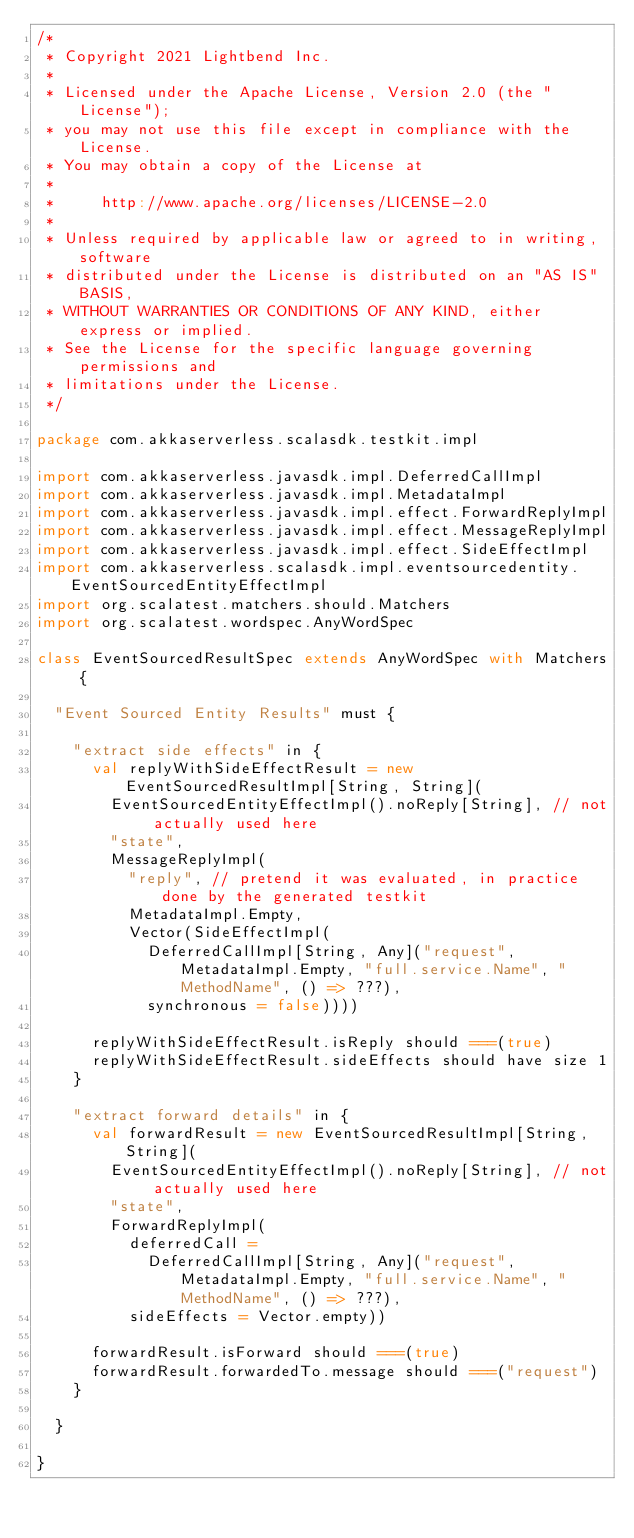Convert code to text. <code><loc_0><loc_0><loc_500><loc_500><_Scala_>/*
 * Copyright 2021 Lightbend Inc.
 *
 * Licensed under the Apache License, Version 2.0 (the "License");
 * you may not use this file except in compliance with the License.
 * You may obtain a copy of the License at
 *
 *     http://www.apache.org/licenses/LICENSE-2.0
 *
 * Unless required by applicable law or agreed to in writing, software
 * distributed under the License is distributed on an "AS IS" BASIS,
 * WITHOUT WARRANTIES OR CONDITIONS OF ANY KIND, either express or implied.
 * See the License for the specific language governing permissions and
 * limitations under the License.
 */

package com.akkaserverless.scalasdk.testkit.impl

import com.akkaserverless.javasdk.impl.DeferredCallImpl
import com.akkaserverless.javasdk.impl.MetadataImpl
import com.akkaserverless.javasdk.impl.effect.ForwardReplyImpl
import com.akkaserverless.javasdk.impl.effect.MessageReplyImpl
import com.akkaserverless.javasdk.impl.effect.SideEffectImpl
import com.akkaserverless.scalasdk.impl.eventsourcedentity.EventSourcedEntityEffectImpl
import org.scalatest.matchers.should.Matchers
import org.scalatest.wordspec.AnyWordSpec

class EventSourcedResultSpec extends AnyWordSpec with Matchers {

  "Event Sourced Entity Results" must {

    "extract side effects" in {
      val replyWithSideEffectResult = new EventSourcedResultImpl[String, String](
        EventSourcedEntityEffectImpl().noReply[String], // not actually used here
        "state",
        MessageReplyImpl(
          "reply", // pretend it was evaluated, in practice done by the generated testkit
          MetadataImpl.Empty,
          Vector(SideEffectImpl(
            DeferredCallImpl[String, Any]("request", MetadataImpl.Empty, "full.service.Name", "MethodName", () => ???),
            synchronous = false))))

      replyWithSideEffectResult.isReply should ===(true)
      replyWithSideEffectResult.sideEffects should have size 1
    }

    "extract forward details" in {
      val forwardResult = new EventSourcedResultImpl[String, String](
        EventSourcedEntityEffectImpl().noReply[String], // not actually used here
        "state",
        ForwardReplyImpl(
          deferredCall =
            DeferredCallImpl[String, Any]("request", MetadataImpl.Empty, "full.service.Name", "MethodName", () => ???),
          sideEffects = Vector.empty))

      forwardResult.isForward should ===(true)
      forwardResult.forwardedTo.message should ===("request")
    }

  }

}
</code> 